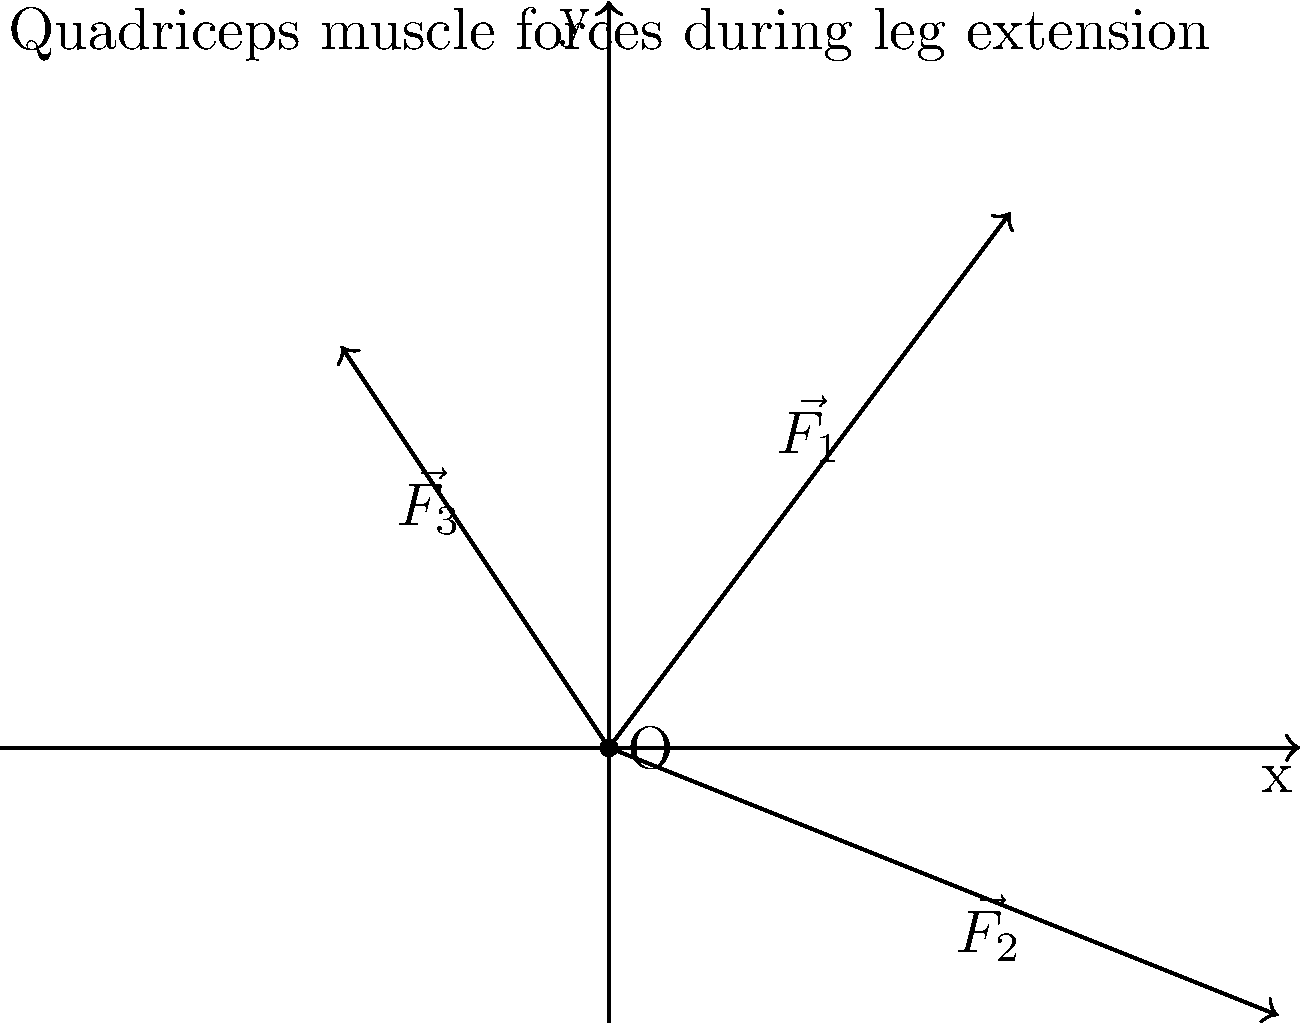During a leg extension exercise, three different portions of the quadriceps muscle group exert forces on the patella as shown in the diagram. $\vec{F_1}$ has a magnitude of 5 N and components (3, 4), $\vec{F_2}$ has a magnitude of $\sqrt{29}$ N and components (5, -2), and $\vec{F_3}$ has a magnitude of $\sqrt{13}$ N and components (-2, 3). Calculate the magnitude of the resultant force vector acting on the patella. To find the magnitude of the resultant force vector, we need to follow these steps:

1) First, we need to add the x and y components of all three force vectors:

   x-component: $3 + 5 + (-2) = 6$ N
   y-component: $4 + (-2) + 3 = 5$ N

2) The resultant force vector $\vec{R}$ has components (6, 5).

3) To find the magnitude of the resultant force vector, we use the Pythagorean theorem:

   $|\vec{R}| = \sqrt{x^2 + y^2}$

4) Substituting our values:

   $|\vec{R}| = \sqrt{6^2 + 5^2}$

5) Simplify:

   $|\vec{R}| = \sqrt{36 + 25} = \sqrt{61}$

Therefore, the magnitude of the resultant force vector is $\sqrt{61}$ N.
Answer: $\sqrt{61}$ N 